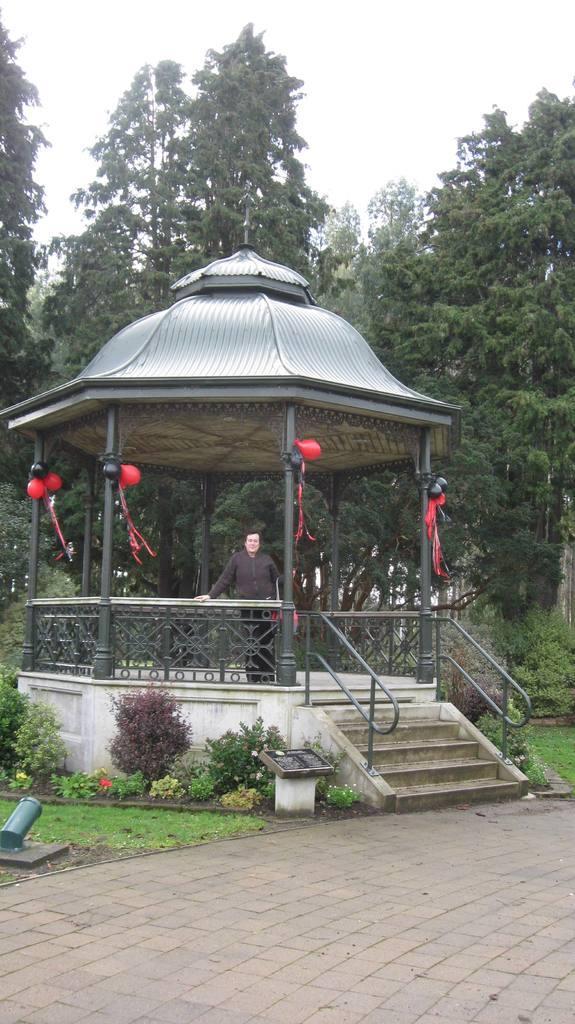Can you describe this image briefly? In this image there is a person standing, leaning on a metal rod fence, in front of the person there are stairs with metal rods, on top of the person there is a rooftop and there are balloons on the pillars, in front of the person there are flowers on plants and there are some objects, behind the person there are trees. 